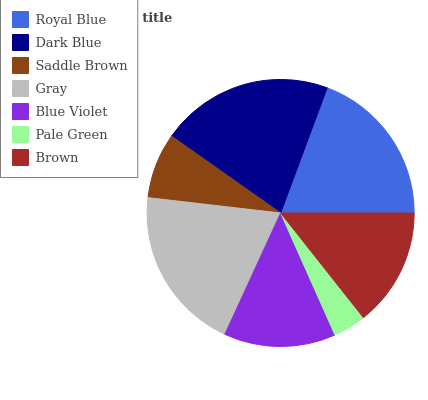Is Pale Green the minimum?
Answer yes or no. Yes. Is Dark Blue the maximum?
Answer yes or no. Yes. Is Saddle Brown the minimum?
Answer yes or no. No. Is Saddle Brown the maximum?
Answer yes or no. No. Is Dark Blue greater than Saddle Brown?
Answer yes or no. Yes. Is Saddle Brown less than Dark Blue?
Answer yes or no. Yes. Is Saddle Brown greater than Dark Blue?
Answer yes or no. No. Is Dark Blue less than Saddle Brown?
Answer yes or no. No. Is Brown the high median?
Answer yes or no. Yes. Is Brown the low median?
Answer yes or no. Yes. Is Gray the high median?
Answer yes or no. No. Is Pale Green the low median?
Answer yes or no. No. 